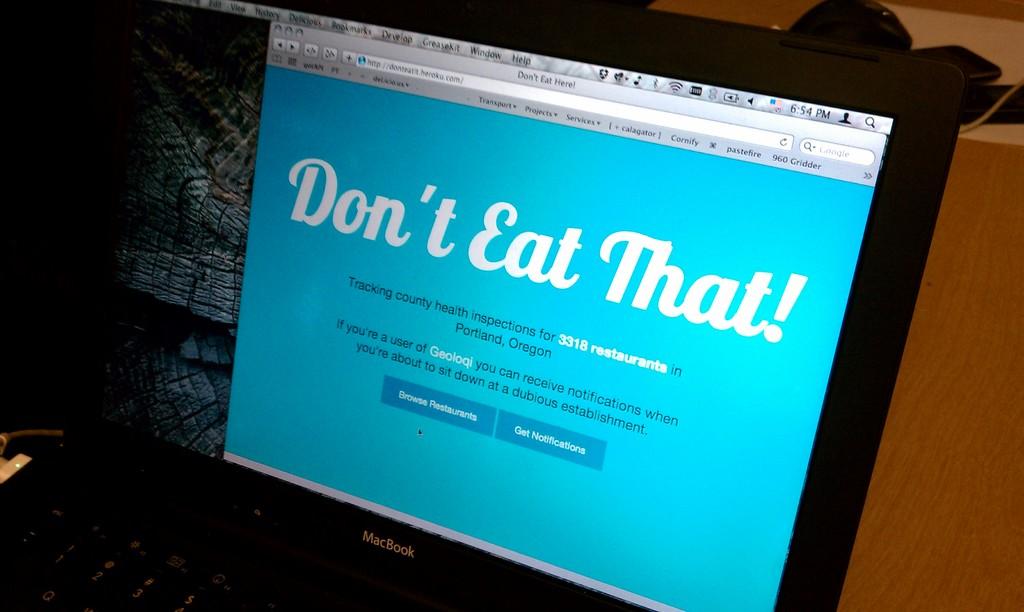What does the computer screen say?
Offer a terse response. Dont eat that. 